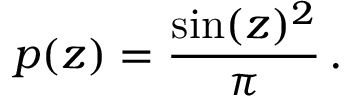Convert formula to latex. <formula><loc_0><loc_0><loc_500><loc_500>p ( z ) = \frac { \sin ( z ) ^ { 2 } } { \pi } \, .</formula> 